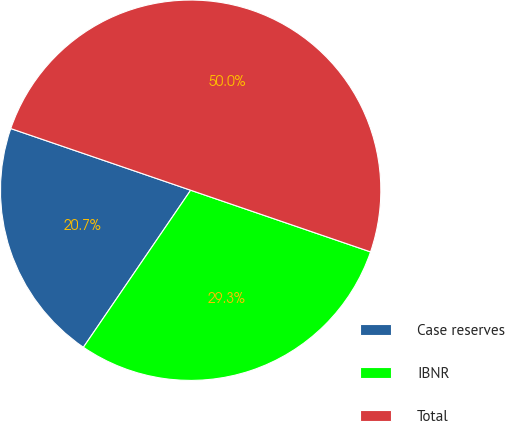<chart> <loc_0><loc_0><loc_500><loc_500><pie_chart><fcel>Case reserves<fcel>IBNR<fcel>Total<nl><fcel>20.72%<fcel>29.28%<fcel>50.0%<nl></chart> 